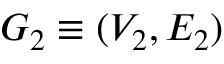<formula> <loc_0><loc_0><loc_500><loc_500>G _ { 2 } \equiv ( V _ { 2 } , E _ { 2 } )</formula> 